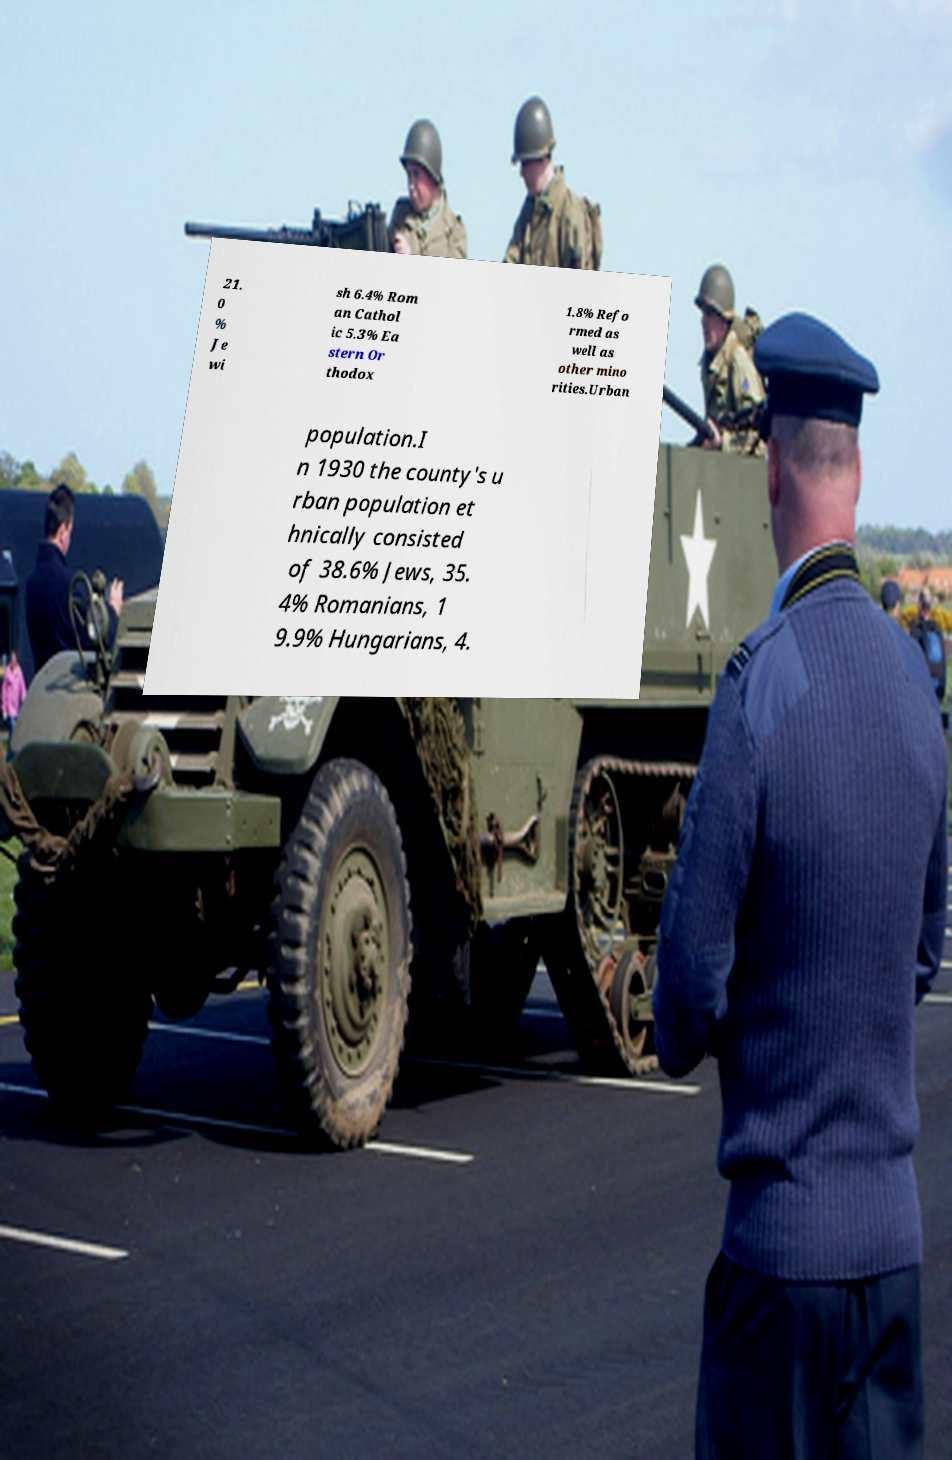I need the written content from this picture converted into text. Can you do that? 21. 0 % Je wi sh 6.4% Rom an Cathol ic 5.3% Ea stern Or thodox 1.8% Refo rmed as well as other mino rities.Urban population.I n 1930 the county's u rban population et hnically consisted of 38.6% Jews, 35. 4% Romanians, 1 9.9% Hungarians, 4. 